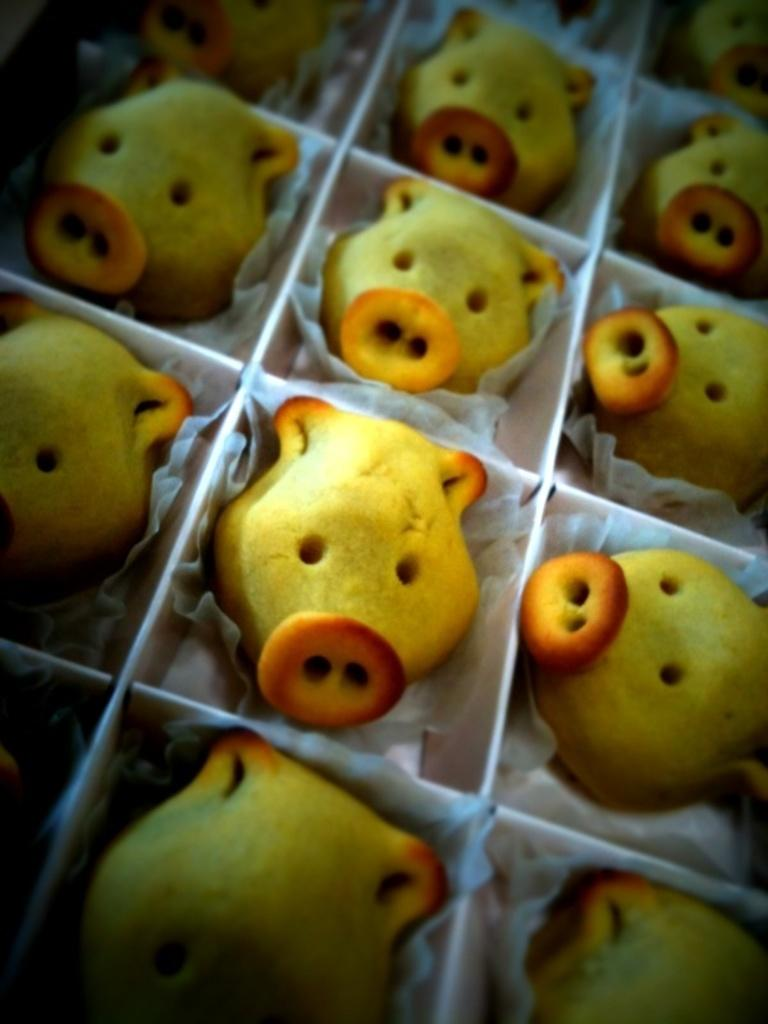What type of cupcakes are shown in the image? There are pig face cupcakes in the image. What colors are the pig face cupcakes? The cupcakes are in yellow and brown colors. What type of door can be seen in the image? There is no door present in the image; it features pig face cupcakes in yellow and brown colors. What type of drink is being served alongside the cupcakes in the image? There is no drink present in the image; it only shows pig face cupcakes in yellow and brown colors. 